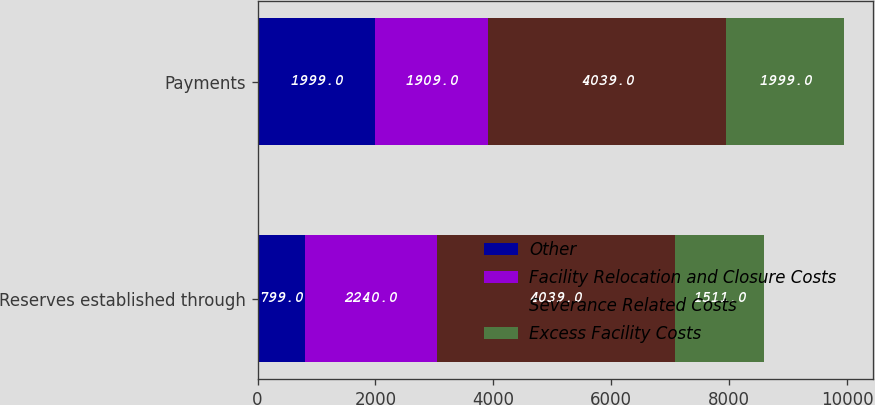<chart> <loc_0><loc_0><loc_500><loc_500><stacked_bar_chart><ecel><fcel>Reserves established through<fcel>Payments<nl><fcel>Other<fcel>799<fcel>1999<nl><fcel>Facility Relocation and Closure Costs<fcel>2240<fcel>1909<nl><fcel>Severance Related Costs<fcel>4039<fcel>4039<nl><fcel>Excess Facility Costs<fcel>1511<fcel>1999<nl></chart> 